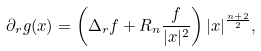Convert formula to latex. <formula><loc_0><loc_0><loc_500><loc_500>\partial _ { r } g ( x ) & = \left ( \Delta _ { r } f + R _ { n } \frac { f } { | x | ^ { 2 } } \right ) | x | ^ { \frac { n + 2 } { 2 } } ,</formula> 